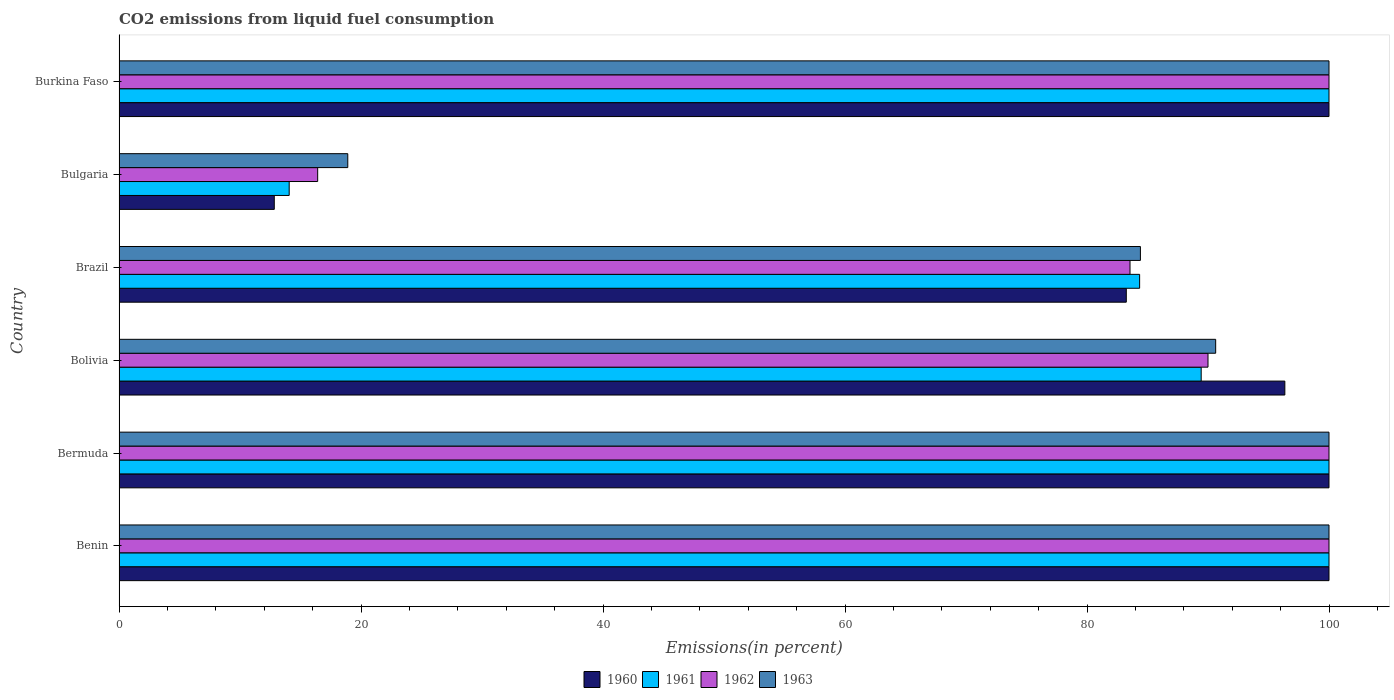Are the number of bars per tick equal to the number of legend labels?
Offer a terse response. Yes. How many bars are there on the 3rd tick from the bottom?
Give a very brief answer. 4. What is the label of the 2nd group of bars from the top?
Your answer should be very brief. Bulgaria. Across all countries, what is the minimum total CO2 emitted in 1962?
Provide a succinct answer. 16.42. In which country was the total CO2 emitted in 1963 maximum?
Keep it short and to the point. Benin. What is the total total CO2 emitted in 1962 in the graph?
Your answer should be very brief. 489.97. What is the difference between the total CO2 emitted in 1961 in Bolivia and the total CO2 emitted in 1963 in Bermuda?
Provide a short and direct response. -10.56. What is the average total CO2 emitted in 1963 per country?
Keep it short and to the point. 82.33. In how many countries, is the total CO2 emitted in 1961 greater than 48 %?
Provide a short and direct response. 5. What is the ratio of the total CO2 emitted in 1963 in Brazil to that in Burkina Faso?
Your response must be concise. 0.84. Is the total CO2 emitted in 1960 in Bermuda less than that in Brazil?
Your response must be concise. No. Is the difference between the total CO2 emitted in 1961 in Benin and Burkina Faso greater than the difference between the total CO2 emitted in 1962 in Benin and Burkina Faso?
Provide a succinct answer. No. What is the difference between the highest and the second highest total CO2 emitted in 1963?
Your answer should be very brief. 0. What is the difference between the highest and the lowest total CO2 emitted in 1960?
Provide a short and direct response. 87.17. What does the 4th bar from the bottom in Brazil represents?
Make the answer very short. 1963. Is it the case that in every country, the sum of the total CO2 emitted in 1962 and total CO2 emitted in 1963 is greater than the total CO2 emitted in 1960?
Ensure brevity in your answer.  Yes. How many bars are there?
Keep it short and to the point. 24. Are all the bars in the graph horizontal?
Make the answer very short. Yes. What is the difference between two consecutive major ticks on the X-axis?
Make the answer very short. 20. Does the graph contain any zero values?
Ensure brevity in your answer.  No. Does the graph contain grids?
Make the answer very short. No. Where does the legend appear in the graph?
Ensure brevity in your answer.  Bottom center. How many legend labels are there?
Provide a short and direct response. 4. What is the title of the graph?
Offer a very short reply. CO2 emissions from liquid fuel consumption. Does "1987" appear as one of the legend labels in the graph?
Your answer should be compact. No. What is the label or title of the X-axis?
Provide a short and direct response. Emissions(in percent). What is the Emissions(in percent) in 1961 in Benin?
Provide a short and direct response. 100. What is the Emissions(in percent) of 1961 in Bermuda?
Offer a terse response. 100. What is the Emissions(in percent) in 1960 in Bolivia?
Keep it short and to the point. 96.35. What is the Emissions(in percent) of 1961 in Bolivia?
Offer a terse response. 89.44. What is the Emissions(in percent) of 1963 in Bolivia?
Provide a succinct answer. 90.63. What is the Emissions(in percent) of 1960 in Brazil?
Offer a very short reply. 83.25. What is the Emissions(in percent) of 1961 in Brazil?
Ensure brevity in your answer.  84.35. What is the Emissions(in percent) of 1962 in Brazil?
Provide a short and direct response. 83.56. What is the Emissions(in percent) in 1963 in Brazil?
Ensure brevity in your answer.  84.41. What is the Emissions(in percent) of 1960 in Bulgaria?
Your answer should be compact. 12.83. What is the Emissions(in percent) in 1961 in Bulgaria?
Your answer should be very brief. 14.06. What is the Emissions(in percent) of 1962 in Bulgaria?
Make the answer very short. 16.42. What is the Emissions(in percent) of 1963 in Bulgaria?
Offer a very short reply. 18.9. What is the Emissions(in percent) in 1960 in Burkina Faso?
Give a very brief answer. 100. What is the Emissions(in percent) of 1962 in Burkina Faso?
Ensure brevity in your answer.  100. What is the Emissions(in percent) in 1963 in Burkina Faso?
Offer a very short reply. 100. Across all countries, what is the maximum Emissions(in percent) in 1962?
Make the answer very short. 100. Across all countries, what is the maximum Emissions(in percent) of 1963?
Keep it short and to the point. 100. Across all countries, what is the minimum Emissions(in percent) of 1960?
Ensure brevity in your answer.  12.83. Across all countries, what is the minimum Emissions(in percent) in 1961?
Provide a short and direct response. 14.06. Across all countries, what is the minimum Emissions(in percent) of 1962?
Your answer should be very brief. 16.42. Across all countries, what is the minimum Emissions(in percent) in 1963?
Offer a terse response. 18.9. What is the total Emissions(in percent) in 1960 in the graph?
Provide a succinct answer. 492.43. What is the total Emissions(in percent) in 1961 in the graph?
Your response must be concise. 487.85. What is the total Emissions(in percent) of 1962 in the graph?
Make the answer very short. 489.97. What is the total Emissions(in percent) of 1963 in the graph?
Offer a very short reply. 493.95. What is the difference between the Emissions(in percent) in 1960 in Benin and that in Bermuda?
Offer a terse response. 0. What is the difference between the Emissions(in percent) in 1961 in Benin and that in Bermuda?
Provide a succinct answer. 0. What is the difference between the Emissions(in percent) in 1962 in Benin and that in Bermuda?
Your answer should be very brief. 0. What is the difference between the Emissions(in percent) in 1963 in Benin and that in Bermuda?
Your answer should be very brief. 0. What is the difference between the Emissions(in percent) in 1960 in Benin and that in Bolivia?
Your answer should be compact. 3.65. What is the difference between the Emissions(in percent) in 1961 in Benin and that in Bolivia?
Your answer should be compact. 10.56. What is the difference between the Emissions(in percent) in 1963 in Benin and that in Bolivia?
Your answer should be very brief. 9.37. What is the difference between the Emissions(in percent) of 1960 in Benin and that in Brazil?
Provide a short and direct response. 16.75. What is the difference between the Emissions(in percent) in 1961 in Benin and that in Brazil?
Make the answer very short. 15.65. What is the difference between the Emissions(in percent) in 1962 in Benin and that in Brazil?
Your answer should be compact. 16.44. What is the difference between the Emissions(in percent) in 1963 in Benin and that in Brazil?
Your answer should be very brief. 15.59. What is the difference between the Emissions(in percent) in 1960 in Benin and that in Bulgaria?
Your response must be concise. 87.17. What is the difference between the Emissions(in percent) of 1961 in Benin and that in Bulgaria?
Offer a very short reply. 85.94. What is the difference between the Emissions(in percent) of 1962 in Benin and that in Bulgaria?
Your answer should be compact. 83.58. What is the difference between the Emissions(in percent) in 1963 in Benin and that in Bulgaria?
Offer a very short reply. 81.1. What is the difference between the Emissions(in percent) of 1960 in Benin and that in Burkina Faso?
Your response must be concise. 0. What is the difference between the Emissions(in percent) in 1962 in Benin and that in Burkina Faso?
Your answer should be very brief. 0. What is the difference between the Emissions(in percent) of 1960 in Bermuda and that in Bolivia?
Your response must be concise. 3.65. What is the difference between the Emissions(in percent) in 1961 in Bermuda and that in Bolivia?
Make the answer very short. 10.56. What is the difference between the Emissions(in percent) of 1963 in Bermuda and that in Bolivia?
Make the answer very short. 9.37. What is the difference between the Emissions(in percent) of 1960 in Bermuda and that in Brazil?
Your answer should be very brief. 16.75. What is the difference between the Emissions(in percent) of 1961 in Bermuda and that in Brazil?
Offer a terse response. 15.65. What is the difference between the Emissions(in percent) of 1962 in Bermuda and that in Brazil?
Provide a succinct answer. 16.44. What is the difference between the Emissions(in percent) in 1963 in Bermuda and that in Brazil?
Give a very brief answer. 15.59. What is the difference between the Emissions(in percent) of 1960 in Bermuda and that in Bulgaria?
Offer a very short reply. 87.17. What is the difference between the Emissions(in percent) in 1961 in Bermuda and that in Bulgaria?
Provide a short and direct response. 85.94. What is the difference between the Emissions(in percent) in 1962 in Bermuda and that in Bulgaria?
Your answer should be compact. 83.58. What is the difference between the Emissions(in percent) of 1963 in Bermuda and that in Bulgaria?
Keep it short and to the point. 81.1. What is the difference between the Emissions(in percent) of 1961 in Bermuda and that in Burkina Faso?
Give a very brief answer. 0. What is the difference between the Emissions(in percent) in 1963 in Bermuda and that in Burkina Faso?
Ensure brevity in your answer.  0. What is the difference between the Emissions(in percent) in 1960 in Bolivia and that in Brazil?
Make the answer very short. 13.1. What is the difference between the Emissions(in percent) of 1961 in Bolivia and that in Brazil?
Offer a very short reply. 5.09. What is the difference between the Emissions(in percent) in 1962 in Bolivia and that in Brazil?
Make the answer very short. 6.44. What is the difference between the Emissions(in percent) of 1963 in Bolivia and that in Brazil?
Offer a very short reply. 6.22. What is the difference between the Emissions(in percent) of 1960 in Bolivia and that in Bulgaria?
Provide a succinct answer. 83.52. What is the difference between the Emissions(in percent) in 1961 in Bolivia and that in Bulgaria?
Your response must be concise. 75.37. What is the difference between the Emissions(in percent) of 1962 in Bolivia and that in Bulgaria?
Provide a short and direct response. 73.58. What is the difference between the Emissions(in percent) in 1963 in Bolivia and that in Bulgaria?
Keep it short and to the point. 71.73. What is the difference between the Emissions(in percent) in 1960 in Bolivia and that in Burkina Faso?
Your answer should be compact. -3.65. What is the difference between the Emissions(in percent) of 1961 in Bolivia and that in Burkina Faso?
Offer a very short reply. -10.56. What is the difference between the Emissions(in percent) in 1963 in Bolivia and that in Burkina Faso?
Provide a succinct answer. -9.37. What is the difference between the Emissions(in percent) of 1960 in Brazil and that in Bulgaria?
Ensure brevity in your answer.  70.42. What is the difference between the Emissions(in percent) in 1961 in Brazil and that in Bulgaria?
Provide a short and direct response. 70.29. What is the difference between the Emissions(in percent) in 1962 in Brazil and that in Bulgaria?
Make the answer very short. 67.14. What is the difference between the Emissions(in percent) in 1963 in Brazil and that in Bulgaria?
Offer a very short reply. 65.51. What is the difference between the Emissions(in percent) in 1960 in Brazil and that in Burkina Faso?
Offer a very short reply. -16.75. What is the difference between the Emissions(in percent) in 1961 in Brazil and that in Burkina Faso?
Give a very brief answer. -15.65. What is the difference between the Emissions(in percent) in 1962 in Brazil and that in Burkina Faso?
Give a very brief answer. -16.44. What is the difference between the Emissions(in percent) in 1963 in Brazil and that in Burkina Faso?
Your response must be concise. -15.59. What is the difference between the Emissions(in percent) in 1960 in Bulgaria and that in Burkina Faso?
Ensure brevity in your answer.  -87.17. What is the difference between the Emissions(in percent) of 1961 in Bulgaria and that in Burkina Faso?
Keep it short and to the point. -85.94. What is the difference between the Emissions(in percent) in 1962 in Bulgaria and that in Burkina Faso?
Offer a very short reply. -83.58. What is the difference between the Emissions(in percent) of 1963 in Bulgaria and that in Burkina Faso?
Your response must be concise. -81.1. What is the difference between the Emissions(in percent) of 1960 in Benin and the Emissions(in percent) of 1961 in Bermuda?
Your answer should be compact. 0. What is the difference between the Emissions(in percent) in 1960 in Benin and the Emissions(in percent) in 1963 in Bermuda?
Make the answer very short. 0. What is the difference between the Emissions(in percent) in 1961 in Benin and the Emissions(in percent) in 1962 in Bermuda?
Your response must be concise. 0. What is the difference between the Emissions(in percent) in 1962 in Benin and the Emissions(in percent) in 1963 in Bermuda?
Make the answer very short. 0. What is the difference between the Emissions(in percent) of 1960 in Benin and the Emissions(in percent) of 1961 in Bolivia?
Make the answer very short. 10.56. What is the difference between the Emissions(in percent) of 1960 in Benin and the Emissions(in percent) of 1962 in Bolivia?
Give a very brief answer. 10. What is the difference between the Emissions(in percent) of 1960 in Benin and the Emissions(in percent) of 1963 in Bolivia?
Keep it short and to the point. 9.37. What is the difference between the Emissions(in percent) of 1961 in Benin and the Emissions(in percent) of 1963 in Bolivia?
Your answer should be compact. 9.37. What is the difference between the Emissions(in percent) in 1962 in Benin and the Emissions(in percent) in 1963 in Bolivia?
Ensure brevity in your answer.  9.37. What is the difference between the Emissions(in percent) of 1960 in Benin and the Emissions(in percent) of 1961 in Brazil?
Provide a succinct answer. 15.65. What is the difference between the Emissions(in percent) of 1960 in Benin and the Emissions(in percent) of 1962 in Brazil?
Your response must be concise. 16.44. What is the difference between the Emissions(in percent) of 1960 in Benin and the Emissions(in percent) of 1963 in Brazil?
Your response must be concise. 15.59. What is the difference between the Emissions(in percent) in 1961 in Benin and the Emissions(in percent) in 1962 in Brazil?
Make the answer very short. 16.44. What is the difference between the Emissions(in percent) of 1961 in Benin and the Emissions(in percent) of 1963 in Brazil?
Give a very brief answer. 15.59. What is the difference between the Emissions(in percent) of 1962 in Benin and the Emissions(in percent) of 1963 in Brazil?
Your answer should be very brief. 15.59. What is the difference between the Emissions(in percent) of 1960 in Benin and the Emissions(in percent) of 1961 in Bulgaria?
Provide a succinct answer. 85.94. What is the difference between the Emissions(in percent) in 1960 in Benin and the Emissions(in percent) in 1962 in Bulgaria?
Your answer should be very brief. 83.58. What is the difference between the Emissions(in percent) in 1960 in Benin and the Emissions(in percent) in 1963 in Bulgaria?
Your answer should be very brief. 81.1. What is the difference between the Emissions(in percent) of 1961 in Benin and the Emissions(in percent) of 1962 in Bulgaria?
Provide a succinct answer. 83.58. What is the difference between the Emissions(in percent) of 1961 in Benin and the Emissions(in percent) of 1963 in Bulgaria?
Provide a succinct answer. 81.1. What is the difference between the Emissions(in percent) of 1962 in Benin and the Emissions(in percent) of 1963 in Bulgaria?
Provide a short and direct response. 81.1. What is the difference between the Emissions(in percent) in 1960 in Benin and the Emissions(in percent) in 1963 in Burkina Faso?
Make the answer very short. 0. What is the difference between the Emissions(in percent) of 1962 in Benin and the Emissions(in percent) of 1963 in Burkina Faso?
Your answer should be compact. 0. What is the difference between the Emissions(in percent) in 1960 in Bermuda and the Emissions(in percent) in 1961 in Bolivia?
Make the answer very short. 10.56. What is the difference between the Emissions(in percent) in 1960 in Bermuda and the Emissions(in percent) in 1962 in Bolivia?
Offer a terse response. 10. What is the difference between the Emissions(in percent) in 1960 in Bermuda and the Emissions(in percent) in 1963 in Bolivia?
Provide a short and direct response. 9.37. What is the difference between the Emissions(in percent) of 1961 in Bermuda and the Emissions(in percent) of 1963 in Bolivia?
Your answer should be very brief. 9.37. What is the difference between the Emissions(in percent) in 1962 in Bermuda and the Emissions(in percent) in 1963 in Bolivia?
Make the answer very short. 9.37. What is the difference between the Emissions(in percent) of 1960 in Bermuda and the Emissions(in percent) of 1961 in Brazil?
Offer a very short reply. 15.65. What is the difference between the Emissions(in percent) in 1960 in Bermuda and the Emissions(in percent) in 1962 in Brazil?
Provide a succinct answer. 16.44. What is the difference between the Emissions(in percent) of 1960 in Bermuda and the Emissions(in percent) of 1963 in Brazil?
Your answer should be compact. 15.59. What is the difference between the Emissions(in percent) in 1961 in Bermuda and the Emissions(in percent) in 1962 in Brazil?
Your answer should be very brief. 16.44. What is the difference between the Emissions(in percent) in 1961 in Bermuda and the Emissions(in percent) in 1963 in Brazil?
Make the answer very short. 15.59. What is the difference between the Emissions(in percent) in 1962 in Bermuda and the Emissions(in percent) in 1963 in Brazil?
Offer a terse response. 15.59. What is the difference between the Emissions(in percent) in 1960 in Bermuda and the Emissions(in percent) in 1961 in Bulgaria?
Offer a very short reply. 85.94. What is the difference between the Emissions(in percent) of 1960 in Bermuda and the Emissions(in percent) of 1962 in Bulgaria?
Give a very brief answer. 83.58. What is the difference between the Emissions(in percent) of 1960 in Bermuda and the Emissions(in percent) of 1963 in Bulgaria?
Your response must be concise. 81.1. What is the difference between the Emissions(in percent) in 1961 in Bermuda and the Emissions(in percent) in 1962 in Bulgaria?
Your response must be concise. 83.58. What is the difference between the Emissions(in percent) in 1961 in Bermuda and the Emissions(in percent) in 1963 in Bulgaria?
Your answer should be very brief. 81.1. What is the difference between the Emissions(in percent) of 1962 in Bermuda and the Emissions(in percent) of 1963 in Bulgaria?
Provide a succinct answer. 81.1. What is the difference between the Emissions(in percent) of 1960 in Bermuda and the Emissions(in percent) of 1961 in Burkina Faso?
Offer a very short reply. 0. What is the difference between the Emissions(in percent) in 1960 in Bermuda and the Emissions(in percent) in 1962 in Burkina Faso?
Make the answer very short. 0. What is the difference between the Emissions(in percent) in 1960 in Bermuda and the Emissions(in percent) in 1963 in Burkina Faso?
Offer a terse response. 0. What is the difference between the Emissions(in percent) of 1961 in Bermuda and the Emissions(in percent) of 1962 in Burkina Faso?
Offer a very short reply. 0. What is the difference between the Emissions(in percent) of 1961 in Bermuda and the Emissions(in percent) of 1963 in Burkina Faso?
Your answer should be very brief. 0. What is the difference between the Emissions(in percent) of 1960 in Bolivia and the Emissions(in percent) of 1961 in Brazil?
Provide a short and direct response. 12. What is the difference between the Emissions(in percent) of 1960 in Bolivia and the Emissions(in percent) of 1962 in Brazil?
Keep it short and to the point. 12.8. What is the difference between the Emissions(in percent) in 1960 in Bolivia and the Emissions(in percent) in 1963 in Brazil?
Your answer should be compact. 11.94. What is the difference between the Emissions(in percent) in 1961 in Bolivia and the Emissions(in percent) in 1962 in Brazil?
Ensure brevity in your answer.  5.88. What is the difference between the Emissions(in percent) of 1961 in Bolivia and the Emissions(in percent) of 1963 in Brazil?
Your response must be concise. 5.02. What is the difference between the Emissions(in percent) of 1962 in Bolivia and the Emissions(in percent) of 1963 in Brazil?
Make the answer very short. 5.59. What is the difference between the Emissions(in percent) in 1960 in Bolivia and the Emissions(in percent) in 1961 in Bulgaria?
Your response must be concise. 82.29. What is the difference between the Emissions(in percent) of 1960 in Bolivia and the Emissions(in percent) of 1962 in Bulgaria?
Give a very brief answer. 79.93. What is the difference between the Emissions(in percent) in 1960 in Bolivia and the Emissions(in percent) in 1963 in Bulgaria?
Offer a very short reply. 77.45. What is the difference between the Emissions(in percent) in 1961 in Bolivia and the Emissions(in percent) in 1962 in Bulgaria?
Keep it short and to the point. 73.02. What is the difference between the Emissions(in percent) of 1961 in Bolivia and the Emissions(in percent) of 1963 in Bulgaria?
Your response must be concise. 70.53. What is the difference between the Emissions(in percent) of 1962 in Bolivia and the Emissions(in percent) of 1963 in Bulgaria?
Give a very brief answer. 71.1. What is the difference between the Emissions(in percent) in 1960 in Bolivia and the Emissions(in percent) in 1961 in Burkina Faso?
Give a very brief answer. -3.65. What is the difference between the Emissions(in percent) of 1960 in Bolivia and the Emissions(in percent) of 1962 in Burkina Faso?
Offer a very short reply. -3.65. What is the difference between the Emissions(in percent) of 1960 in Bolivia and the Emissions(in percent) of 1963 in Burkina Faso?
Your response must be concise. -3.65. What is the difference between the Emissions(in percent) of 1961 in Bolivia and the Emissions(in percent) of 1962 in Burkina Faso?
Give a very brief answer. -10.56. What is the difference between the Emissions(in percent) in 1961 in Bolivia and the Emissions(in percent) in 1963 in Burkina Faso?
Keep it short and to the point. -10.56. What is the difference between the Emissions(in percent) in 1962 in Bolivia and the Emissions(in percent) in 1963 in Burkina Faso?
Give a very brief answer. -10. What is the difference between the Emissions(in percent) of 1960 in Brazil and the Emissions(in percent) of 1961 in Bulgaria?
Your response must be concise. 69.19. What is the difference between the Emissions(in percent) in 1960 in Brazil and the Emissions(in percent) in 1962 in Bulgaria?
Offer a very short reply. 66.83. What is the difference between the Emissions(in percent) in 1960 in Brazil and the Emissions(in percent) in 1963 in Bulgaria?
Offer a very short reply. 64.34. What is the difference between the Emissions(in percent) in 1961 in Brazil and the Emissions(in percent) in 1962 in Bulgaria?
Your answer should be very brief. 67.93. What is the difference between the Emissions(in percent) in 1961 in Brazil and the Emissions(in percent) in 1963 in Bulgaria?
Give a very brief answer. 65.44. What is the difference between the Emissions(in percent) of 1962 in Brazil and the Emissions(in percent) of 1963 in Bulgaria?
Give a very brief answer. 64.65. What is the difference between the Emissions(in percent) of 1960 in Brazil and the Emissions(in percent) of 1961 in Burkina Faso?
Provide a succinct answer. -16.75. What is the difference between the Emissions(in percent) in 1960 in Brazil and the Emissions(in percent) in 1962 in Burkina Faso?
Your answer should be very brief. -16.75. What is the difference between the Emissions(in percent) of 1960 in Brazil and the Emissions(in percent) of 1963 in Burkina Faso?
Provide a succinct answer. -16.75. What is the difference between the Emissions(in percent) of 1961 in Brazil and the Emissions(in percent) of 1962 in Burkina Faso?
Ensure brevity in your answer.  -15.65. What is the difference between the Emissions(in percent) of 1961 in Brazil and the Emissions(in percent) of 1963 in Burkina Faso?
Your response must be concise. -15.65. What is the difference between the Emissions(in percent) in 1962 in Brazil and the Emissions(in percent) in 1963 in Burkina Faso?
Ensure brevity in your answer.  -16.44. What is the difference between the Emissions(in percent) in 1960 in Bulgaria and the Emissions(in percent) in 1961 in Burkina Faso?
Make the answer very short. -87.17. What is the difference between the Emissions(in percent) of 1960 in Bulgaria and the Emissions(in percent) of 1962 in Burkina Faso?
Your answer should be very brief. -87.17. What is the difference between the Emissions(in percent) in 1960 in Bulgaria and the Emissions(in percent) in 1963 in Burkina Faso?
Provide a short and direct response. -87.17. What is the difference between the Emissions(in percent) in 1961 in Bulgaria and the Emissions(in percent) in 1962 in Burkina Faso?
Keep it short and to the point. -85.94. What is the difference between the Emissions(in percent) in 1961 in Bulgaria and the Emissions(in percent) in 1963 in Burkina Faso?
Provide a succinct answer. -85.94. What is the difference between the Emissions(in percent) in 1962 in Bulgaria and the Emissions(in percent) in 1963 in Burkina Faso?
Offer a terse response. -83.58. What is the average Emissions(in percent) in 1960 per country?
Ensure brevity in your answer.  82.07. What is the average Emissions(in percent) of 1961 per country?
Offer a very short reply. 81.31. What is the average Emissions(in percent) in 1962 per country?
Give a very brief answer. 81.66. What is the average Emissions(in percent) of 1963 per country?
Keep it short and to the point. 82.33. What is the difference between the Emissions(in percent) in 1960 and Emissions(in percent) in 1962 in Benin?
Your response must be concise. 0. What is the difference between the Emissions(in percent) in 1960 and Emissions(in percent) in 1963 in Benin?
Provide a short and direct response. 0. What is the difference between the Emissions(in percent) in 1962 and Emissions(in percent) in 1963 in Benin?
Your answer should be very brief. 0. What is the difference between the Emissions(in percent) in 1960 and Emissions(in percent) in 1963 in Bermuda?
Provide a short and direct response. 0. What is the difference between the Emissions(in percent) in 1961 and Emissions(in percent) in 1962 in Bermuda?
Keep it short and to the point. 0. What is the difference between the Emissions(in percent) in 1961 and Emissions(in percent) in 1963 in Bermuda?
Give a very brief answer. 0. What is the difference between the Emissions(in percent) of 1960 and Emissions(in percent) of 1961 in Bolivia?
Offer a terse response. 6.91. What is the difference between the Emissions(in percent) of 1960 and Emissions(in percent) of 1962 in Bolivia?
Give a very brief answer. 6.35. What is the difference between the Emissions(in percent) in 1960 and Emissions(in percent) in 1963 in Bolivia?
Offer a very short reply. 5.72. What is the difference between the Emissions(in percent) in 1961 and Emissions(in percent) in 1962 in Bolivia?
Provide a succinct answer. -0.56. What is the difference between the Emissions(in percent) of 1961 and Emissions(in percent) of 1963 in Bolivia?
Provide a short and direct response. -1.2. What is the difference between the Emissions(in percent) of 1962 and Emissions(in percent) of 1963 in Bolivia?
Your answer should be compact. -0.63. What is the difference between the Emissions(in percent) in 1960 and Emissions(in percent) in 1961 in Brazil?
Your answer should be compact. -1.1. What is the difference between the Emissions(in percent) in 1960 and Emissions(in percent) in 1962 in Brazil?
Provide a succinct answer. -0.31. What is the difference between the Emissions(in percent) in 1960 and Emissions(in percent) in 1963 in Brazil?
Your answer should be very brief. -1.17. What is the difference between the Emissions(in percent) in 1961 and Emissions(in percent) in 1962 in Brazil?
Offer a terse response. 0.79. What is the difference between the Emissions(in percent) in 1961 and Emissions(in percent) in 1963 in Brazil?
Your answer should be compact. -0.06. What is the difference between the Emissions(in percent) of 1962 and Emissions(in percent) of 1963 in Brazil?
Offer a terse response. -0.86. What is the difference between the Emissions(in percent) in 1960 and Emissions(in percent) in 1961 in Bulgaria?
Make the answer very short. -1.23. What is the difference between the Emissions(in percent) of 1960 and Emissions(in percent) of 1962 in Bulgaria?
Your answer should be very brief. -3.59. What is the difference between the Emissions(in percent) in 1960 and Emissions(in percent) in 1963 in Bulgaria?
Make the answer very short. -6.08. What is the difference between the Emissions(in percent) in 1961 and Emissions(in percent) in 1962 in Bulgaria?
Offer a very short reply. -2.35. What is the difference between the Emissions(in percent) of 1961 and Emissions(in percent) of 1963 in Bulgaria?
Offer a very short reply. -4.84. What is the difference between the Emissions(in percent) in 1962 and Emissions(in percent) in 1963 in Bulgaria?
Give a very brief answer. -2.49. What is the difference between the Emissions(in percent) in 1960 and Emissions(in percent) in 1961 in Burkina Faso?
Keep it short and to the point. 0. What is the difference between the Emissions(in percent) in 1962 and Emissions(in percent) in 1963 in Burkina Faso?
Give a very brief answer. 0. What is the ratio of the Emissions(in percent) of 1961 in Benin to that in Bermuda?
Give a very brief answer. 1. What is the ratio of the Emissions(in percent) of 1963 in Benin to that in Bermuda?
Provide a succinct answer. 1. What is the ratio of the Emissions(in percent) in 1960 in Benin to that in Bolivia?
Give a very brief answer. 1.04. What is the ratio of the Emissions(in percent) in 1961 in Benin to that in Bolivia?
Make the answer very short. 1.12. What is the ratio of the Emissions(in percent) of 1963 in Benin to that in Bolivia?
Your answer should be very brief. 1.1. What is the ratio of the Emissions(in percent) in 1960 in Benin to that in Brazil?
Your response must be concise. 1.2. What is the ratio of the Emissions(in percent) in 1961 in Benin to that in Brazil?
Keep it short and to the point. 1.19. What is the ratio of the Emissions(in percent) of 1962 in Benin to that in Brazil?
Keep it short and to the point. 1.2. What is the ratio of the Emissions(in percent) in 1963 in Benin to that in Brazil?
Provide a succinct answer. 1.18. What is the ratio of the Emissions(in percent) in 1960 in Benin to that in Bulgaria?
Offer a very short reply. 7.79. What is the ratio of the Emissions(in percent) in 1961 in Benin to that in Bulgaria?
Offer a terse response. 7.11. What is the ratio of the Emissions(in percent) of 1962 in Benin to that in Bulgaria?
Provide a short and direct response. 6.09. What is the ratio of the Emissions(in percent) of 1963 in Benin to that in Bulgaria?
Your answer should be very brief. 5.29. What is the ratio of the Emissions(in percent) in 1960 in Benin to that in Burkina Faso?
Provide a succinct answer. 1. What is the ratio of the Emissions(in percent) of 1962 in Benin to that in Burkina Faso?
Keep it short and to the point. 1. What is the ratio of the Emissions(in percent) of 1960 in Bermuda to that in Bolivia?
Provide a short and direct response. 1.04. What is the ratio of the Emissions(in percent) in 1961 in Bermuda to that in Bolivia?
Your answer should be very brief. 1.12. What is the ratio of the Emissions(in percent) in 1963 in Bermuda to that in Bolivia?
Give a very brief answer. 1.1. What is the ratio of the Emissions(in percent) in 1960 in Bermuda to that in Brazil?
Keep it short and to the point. 1.2. What is the ratio of the Emissions(in percent) in 1961 in Bermuda to that in Brazil?
Provide a succinct answer. 1.19. What is the ratio of the Emissions(in percent) of 1962 in Bermuda to that in Brazil?
Offer a terse response. 1.2. What is the ratio of the Emissions(in percent) of 1963 in Bermuda to that in Brazil?
Ensure brevity in your answer.  1.18. What is the ratio of the Emissions(in percent) in 1960 in Bermuda to that in Bulgaria?
Ensure brevity in your answer.  7.79. What is the ratio of the Emissions(in percent) of 1961 in Bermuda to that in Bulgaria?
Your response must be concise. 7.11. What is the ratio of the Emissions(in percent) in 1962 in Bermuda to that in Bulgaria?
Keep it short and to the point. 6.09. What is the ratio of the Emissions(in percent) of 1963 in Bermuda to that in Bulgaria?
Give a very brief answer. 5.29. What is the ratio of the Emissions(in percent) in 1960 in Bermuda to that in Burkina Faso?
Keep it short and to the point. 1. What is the ratio of the Emissions(in percent) in 1961 in Bermuda to that in Burkina Faso?
Provide a succinct answer. 1. What is the ratio of the Emissions(in percent) of 1962 in Bermuda to that in Burkina Faso?
Offer a terse response. 1. What is the ratio of the Emissions(in percent) of 1960 in Bolivia to that in Brazil?
Your answer should be compact. 1.16. What is the ratio of the Emissions(in percent) of 1961 in Bolivia to that in Brazil?
Make the answer very short. 1.06. What is the ratio of the Emissions(in percent) of 1962 in Bolivia to that in Brazil?
Your answer should be very brief. 1.08. What is the ratio of the Emissions(in percent) in 1963 in Bolivia to that in Brazil?
Your response must be concise. 1.07. What is the ratio of the Emissions(in percent) in 1960 in Bolivia to that in Bulgaria?
Provide a short and direct response. 7.51. What is the ratio of the Emissions(in percent) in 1961 in Bolivia to that in Bulgaria?
Keep it short and to the point. 6.36. What is the ratio of the Emissions(in percent) in 1962 in Bolivia to that in Bulgaria?
Keep it short and to the point. 5.48. What is the ratio of the Emissions(in percent) in 1963 in Bolivia to that in Bulgaria?
Offer a terse response. 4.79. What is the ratio of the Emissions(in percent) of 1960 in Bolivia to that in Burkina Faso?
Make the answer very short. 0.96. What is the ratio of the Emissions(in percent) in 1961 in Bolivia to that in Burkina Faso?
Your response must be concise. 0.89. What is the ratio of the Emissions(in percent) of 1962 in Bolivia to that in Burkina Faso?
Your response must be concise. 0.9. What is the ratio of the Emissions(in percent) in 1963 in Bolivia to that in Burkina Faso?
Offer a terse response. 0.91. What is the ratio of the Emissions(in percent) in 1960 in Brazil to that in Bulgaria?
Your response must be concise. 6.49. What is the ratio of the Emissions(in percent) in 1961 in Brazil to that in Bulgaria?
Your answer should be compact. 6. What is the ratio of the Emissions(in percent) of 1962 in Brazil to that in Bulgaria?
Keep it short and to the point. 5.09. What is the ratio of the Emissions(in percent) in 1963 in Brazil to that in Bulgaria?
Provide a succinct answer. 4.47. What is the ratio of the Emissions(in percent) in 1960 in Brazil to that in Burkina Faso?
Make the answer very short. 0.83. What is the ratio of the Emissions(in percent) of 1961 in Brazil to that in Burkina Faso?
Provide a succinct answer. 0.84. What is the ratio of the Emissions(in percent) in 1962 in Brazil to that in Burkina Faso?
Your response must be concise. 0.84. What is the ratio of the Emissions(in percent) in 1963 in Brazil to that in Burkina Faso?
Make the answer very short. 0.84. What is the ratio of the Emissions(in percent) of 1960 in Bulgaria to that in Burkina Faso?
Provide a short and direct response. 0.13. What is the ratio of the Emissions(in percent) of 1961 in Bulgaria to that in Burkina Faso?
Give a very brief answer. 0.14. What is the ratio of the Emissions(in percent) in 1962 in Bulgaria to that in Burkina Faso?
Your answer should be compact. 0.16. What is the ratio of the Emissions(in percent) in 1963 in Bulgaria to that in Burkina Faso?
Provide a succinct answer. 0.19. What is the difference between the highest and the second highest Emissions(in percent) in 1961?
Ensure brevity in your answer.  0. What is the difference between the highest and the second highest Emissions(in percent) of 1962?
Make the answer very short. 0. What is the difference between the highest and the lowest Emissions(in percent) of 1960?
Provide a succinct answer. 87.17. What is the difference between the highest and the lowest Emissions(in percent) in 1961?
Your answer should be compact. 85.94. What is the difference between the highest and the lowest Emissions(in percent) in 1962?
Your answer should be very brief. 83.58. What is the difference between the highest and the lowest Emissions(in percent) in 1963?
Your answer should be very brief. 81.1. 